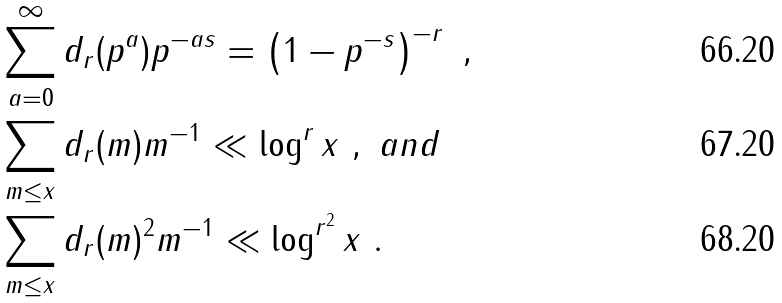<formula> <loc_0><loc_0><loc_500><loc_500>& \sum _ { a = 0 } ^ { \infty } d _ { r } ( p ^ { a } ) p ^ { - a s } = \left ( 1 - p ^ { - s } \right ) ^ { - r } \ , \\ & \sum _ { m \leq x } d _ { r } ( m ) m ^ { - 1 } \ll \log ^ { r } x \ , \ a n d \\ & \sum _ { m \leq x } d _ { r } ( m ) ^ { 2 } m ^ { - 1 } \ll \log ^ { r ^ { 2 } } x \ .</formula> 